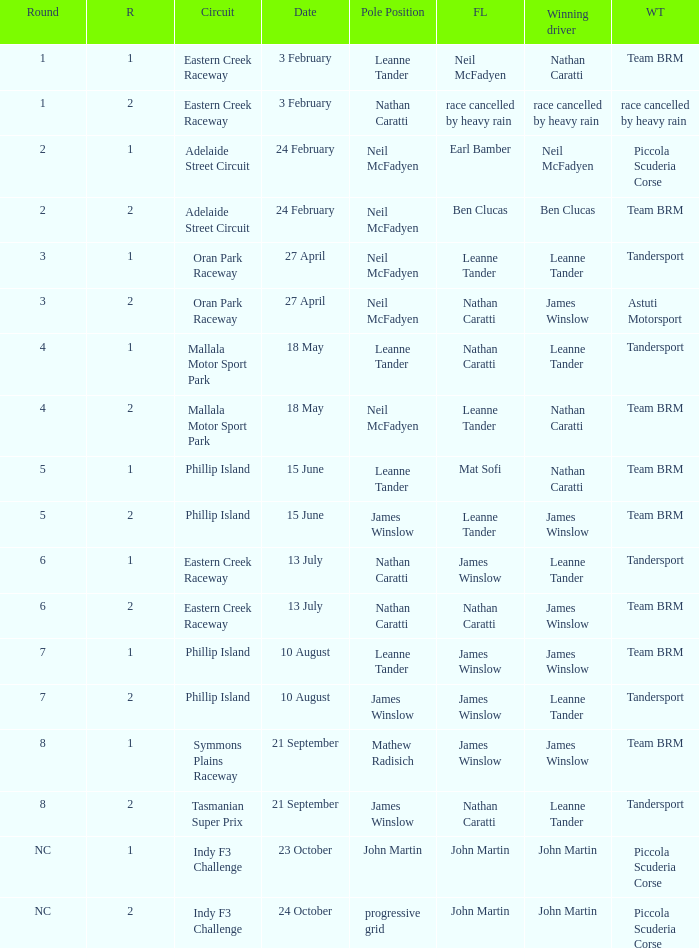What is the highest race number in the Phillip Island circuit with James Winslow as the winning driver and pole position? 2.0. 